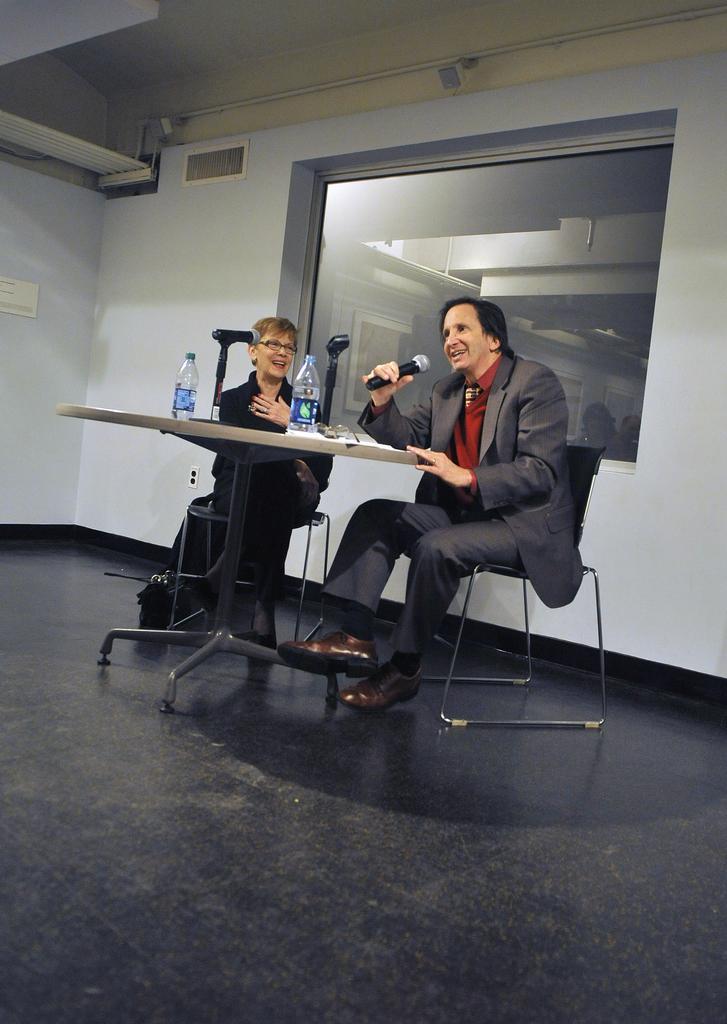In one or two sentences, can you explain what this image depicts? This is the picture taken in a room, there are two persons sitting on a chair. the man in blazer was holding a microphone. In front of these people there is a table on the table there are bottles and paper. Behind the people there are glass window and a wall. 